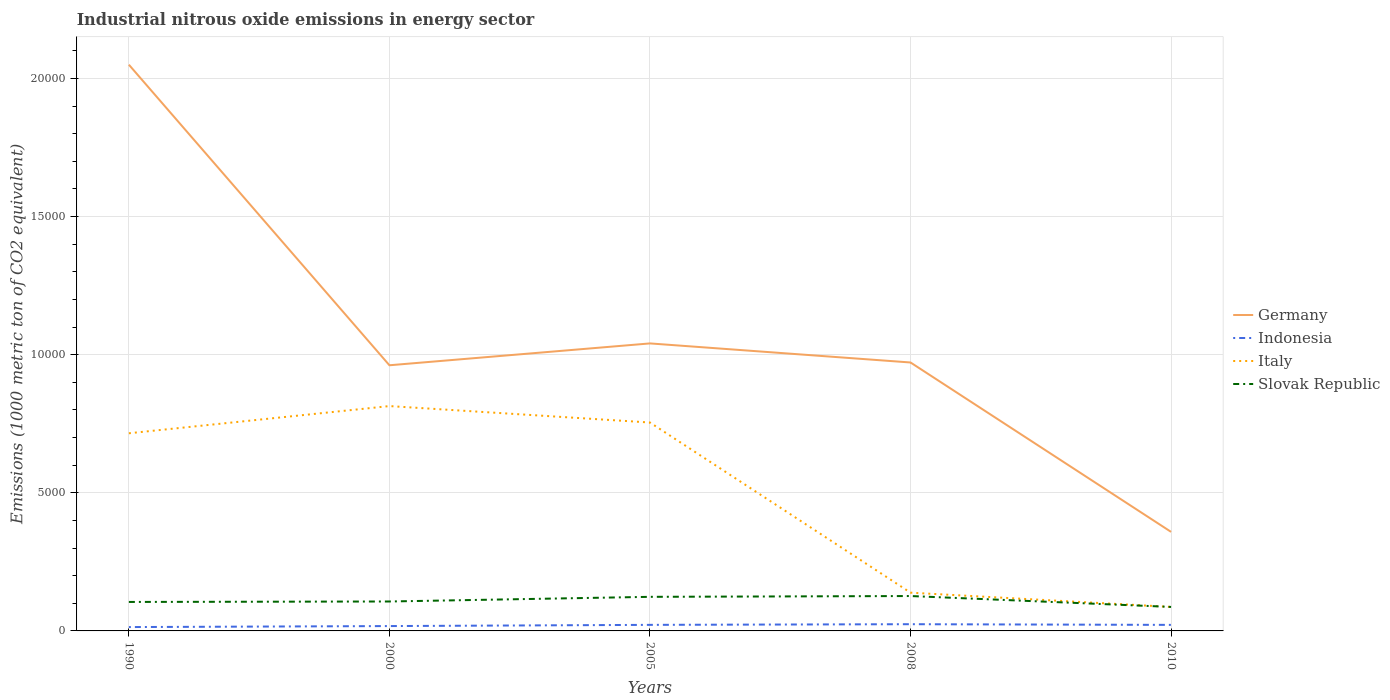How many different coloured lines are there?
Offer a very short reply. 4. Across all years, what is the maximum amount of industrial nitrous oxide emitted in Indonesia?
Offer a very short reply. 139.5. In which year was the amount of industrial nitrous oxide emitted in Germany maximum?
Keep it short and to the point. 2010. What is the total amount of industrial nitrous oxide emitted in Slovak Republic in the graph?
Your answer should be very brief. 394.6. What is the difference between the highest and the second highest amount of industrial nitrous oxide emitted in Slovak Republic?
Your answer should be compact. 394.6. What is the difference between the highest and the lowest amount of industrial nitrous oxide emitted in Italy?
Keep it short and to the point. 3. How many years are there in the graph?
Your response must be concise. 5. What is the difference between two consecutive major ticks on the Y-axis?
Make the answer very short. 5000. Are the values on the major ticks of Y-axis written in scientific E-notation?
Provide a succinct answer. No. How many legend labels are there?
Ensure brevity in your answer.  4. What is the title of the graph?
Offer a very short reply. Industrial nitrous oxide emissions in energy sector. Does "Ethiopia" appear as one of the legend labels in the graph?
Offer a terse response. No. What is the label or title of the X-axis?
Make the answer very short. Years. What is the label or title of the Y-axis?
Your response must be concise. Emissions (1000 metric ton of CO2 equivalent). What is the Emissions (1000 metric ton of CO2 equivalent) of Germany in 1990?
Provide a succinct answer. 2.05e+04. What is the Emissions (1000 metric ton of CO2 equivalent) in Indonesia in 1990?
Keep it short and to the point. 139.5. What is the Emissions (1000 metric ton of CO2 equivalent) in Italy in 1990?
Give a very brief answer. 7155.8. What is the Emissions (1000 metric ton of CO2 equivalent) in Slovak Republic in 1990?
Your response must be concise. 1049. What is the Emissions (1000 metric ton of CO2 equivalent) in Germany in 2000?
Offer a terse response. 9617.9. What is the Emissions (1000 metric ton of CO2 equivalent) of Indonesia in 2000?
Ensure brevity in your answer.  175.8. What is the Emissions (1000 metric ton of CO2 equivalent) of Italy in 2000?
Provide a succinct answer. 8140.4. What is the Emissions (1000 metric ton of CO2 equivalent) in Slovak Republic in 2000?
Provide a short and direct response. 1065.7. What is the Emissions (1000 metric ton of CO2 equivalent) in Germany in 2005?
Provide a succinct answer. 1.04e+04. What is the Emissions (1000 metric ton of CO2 equivalent) of Indonesia in 2005?
Offer a terse response. 219.6. What is the Emissions (1000 metric ton of CO2 equivalent) in Italy in 2005?
Your answer should be very brief. 7544.9. What is the Emissions (1000 metric ton of CO2 equivalent) of Slovak Republic in 2005?
Make the answer very short. 1234.3. What is the Emissions (1000 metric ton of CO2 equivalent) in Germany in 2008?
Your answer should be compact. 9718.4. What is the Emissions (1000 metric ton of CO2 equivalent) in Indonesia in 2008?
Ensure brevity in your answer.  243.3. What is the Emissions (1000 metric ton of CO2 equivalent) of Italy in 2008?
Make the answer very short. 1385.2. What is the Emissions (1000 metric ton of CO2 equivalent) of Slovak Republic in 2008?
Offer a very short reply. 1263.1. What is the Emissions (1000 metric ton of CO2 equivalent) of Germany in 2010?
Your answer should be compact. 3585.4. What is the Emissions (1000 metric ton of CO2 equivalent) of Indonesia in 2010?
Offer a very short reply. 218.6. What is the Emissions (1000 metric ton of CO2 equivalent) in Italy in 2010?
Offer a terse response. 868. What is the Emissions (1000 metric ton of CO2 equivalent) of Slovak Republic in 2010?
Your answer should be compact. 868.5. Across all years, what is the maximum Emissions (1000 metric ton of CO2 equivalent) in Germany?
Provide a short and direct response. 2.05e+04. Across all years, what is the maximum Emissions (1000 metric ton of CO2 equivalent) of Indonesia?
Ensure brevity in your answer.  243.3. Across all years, what is the maximum Emissions (1000 metric ton of CO2 equivalent) of Italy?
Your answer should be very brief. 8140.4. Across all years, what is the maximum Emissions (1000 metric ton of CO2 equivalent) of Slovak Republic?
Offer a terse response. 1263.1. Across all years, what is the minimum Emissions (1000 metric ton of CO2 equivalent) of Germany?
Ensure brevity in your answer.  3585.4. Across all years, what is the minimum Emissions (1000 metric ton of CO2 equivalent) in Indonesia?
Ensure brevity in your answer.  139.5. Across all years, what is the minimum Emissions (1000 metric ton of CO2 equivalent) in Italy?
Provide a short and direct response. 868. Across all years, what is the minimum Emissions (1000 metric ton of CO2 equivalent) in Slovak Republic?
Your response must be concise. 868.5. What is the total Emissions (1000 metric ton of CO2 equivalent) in Germany in the graph?
Provide a short and direct response. 5.38e+04. What is the total Emissions (1000 metric ton of CO2 equivalent) of Indonesia in the graph?
Your response must be concise. 996.8. What is the total Emissions (1000 metric ton of CO2 equivalent) in Italy in the graph?
Make the answer very short. 2.51e+04. What is the total Emissions (1000 metric ton of CO2 equivalent) in Slovak Republic in the graph?
Provide a short and direct response. 5480.6. What is the difference between the Emissions (1000 metric ton of CO2 equivalent) in Germany in 1990 and that in 2000?
Your answer should be compact. 1.09e+04. What is the difference between the Emissions (1000 metric ton of CO2 equivalent) in Indonesia in 1990 and that in 2000?
Offer a very short reply. -36.3. What is the difference between the Emissions (1000 metric ton of CO2 equivalent) of Italy in 1990 and that in 2000?
Your response must be concise. -984.6. What is the difference between the Emissions (1000 metric ton of CO2 equivalent) of Slovak Republic in 1990 and that in 2000?
Offer a very short reply. -16.7. What is the difference between the Emissions (1000 metric ton of CO2 equivalent) of Germany in 1990 and that in 2005?
Make the answer very short. 1.01e+04. What is the difference between the Emissions (1000 metric ton of CO2 equivalent) of Indonesia in 1990 and that in 2005?
Your answer should be very brief. -80.1. What is the difference between the Emissions (1000 metric ton of CO2 equivalent) of Italy in 1990 and that in 2005?
Make the answer very short. -389.1. What is the difference between the Emissions (1000 metric ton of CO2 equivalent) of Slovak Republic in 1990 and that in 2005?
Your answer should be compact. -185.3. What is the difference between the Emissions (1000 metric ton of CO2 equivalent) of Germany in 1990 and that in 2008?
Keep it short and to the point. 1.08e+04. What is the difference between the Emissions (1000 metric ton of CO2 equivalent) of Indonesia in 1990 and that in 2008?
Give a very brief answer. -103.8. What is the difference between the Emissions (1000 metric ton of CO2 equivalent) of Italy in 1990 and that in 2008?
Give a very brief answer. 5770.6. What is the difference between the Emissions (1000 metric ton of CO2 equivalent) in Slovak Republic in 1990 and that in 2008?
Give a very brief answer. -214.1. What is the difference between the Emissions (1000 metric ton of CO2 equivalent) in Germany in 1990 and that in 2010?
Offer a very short reply. 1.69e+04. What is the difference between the Emissions (1000 metric ton of CO2 equivalent) of Indonesia in 1990 and that in 2010?
Make the answer very short. -79.1. What is the difference between the Emissions (1000 metric ton of CO2 equivalent) in Italy in 1990 and that in 2010?
Give a very brief answer. 6287.8. What is the difference between the Emissions (1000 metric ton of CO2 equivalent) of Slovak Republic in 1990 and that in 2010?
Provide a short and direct response. 180.5. What is the difference between the Emissions (1000 metric ton of CO2 equivalent) of Germany in 2000 and that in 2005?
Keep it short and to the point. -791. What is the difference between the Emissions (1000 metric ton of CO2 equivalent) of Indonesia in 2000 and that in 2005?
Offer a terse response. -43.8. What is the difference between the Emissions (1000 metric ton of CO2 equivalent) in Italy in 2000 and that in 2005?
Provide a short and direct response. 595.5. What is the difference between the Emissions (1000 metric ton of CO2 equivalent) of Slovak Republic in 2000 and that in 2005?
Offer a terse response. -168.6. What is the difference between the Emissions (1000 metric ton of CO2 equivalent) of Germany in 2000 and that in 2008?
Your response must be concise. -100.5. What is the difference between the Emissions (1000 metric ton of CO2 equivalent) in Indonesia in 2000 and that in 2008?
Offer a very short reply. -67.5. What is the difference between the Emissions (1000 metric ton of CO2 equivalent) of Italy in 2000 and that in 2008?
Keep it short and to the point. 6755.2. What is the difference between the Emissions (1000 metric ton of CO2 equivalent) in Slovak Republic in 2000 and that in 2008?
Make the answer very short. -197.4. What is the difference between the Emissions (1000 metric ton of CO2 equivalent) of Germany in 2000 and that in 2010?
Give a very brief answer. 6032.5. What is the difference between the Emissions (1000 metric ton of CO2 equivalent) in Indonesia in 2000 and that in 2010?
Provide a short and direct response. -42.8. What is the difference between the Emissions (1000 metric ton of CO2 equivalent) in Italy in 2000 and that in 2010?
Offer a very short reply. 7272.4. What is the difference between the Emissions (1000 metric ton of CO2 equivalent) of Slovak Republic in 2000 and that in 2010?
Make the answer very short. 197.2. What is the difference between the Emissions (1000 metric ton of CO2 equivalent) of Germany in 2005 and that in 2008?
Provide a short and direct response. 690.5. What is the difference between the Emissions (1000 metric ton of CO2 equivalent) of Indonesia in 2005 and that in 2008?
Provide a short and direct response. -23.7. What is the difference between the Emissions (1000 metric ton of CO2 equivalent) of Italy in 2005 and that in 2008?
Your response must be concise. 6159.7. What is the difference between the Emissions (1000 metric ton of CO2 equivalent) in Slovak Republic in 2005 and that in 2008?
Keep it short and to the point. -28.8. What is the difference between the Emissions (1000 metric ton of CO2 equivalent) of Germany in 2005 and that in 2010?
Offer a very short reply. 6823.5. What is the difference between the Emissions (1000 metric ton of CO2 equivalent) in Indonesia in 2005 and that in 2010?
Make the answer very short. 1. What is the difference between the Emissions (1000 metric ton of CO2 equivalent) in Italy in 2005 and that in 2010?
Provide a succinct answer. 6676.9. What is the difference between the Emissions (1000 metric ton of CO2 equivalent) in Slovak Republic in 2005 and that in 2010?
Give a very brief answer. 365.8. What is the difference between the Emissions (1000 metric ton of CO2 equivalent) in Germany in 2008 and that in 2010?
Provide a short and direct response. 6133. What is the difference between the Emissions (1000 metric ton of CO2 equivalent) in Indonesia in 2008 and that in 2010?
Keep it short and to the point. 24.7. What is the difference between the Emissions (1000 metric ton of CO2 equivalent) of Italy in 2008 and that in 2010?
Your answer should be very brief. 517.2. What is the difference between the Emissions (1000 metric ton of CO2 equivalent) in Slovak Republic in 2008 and that in 2010?
Provide a succinct answer. 394.6. What is the difference between the Emissions (1000 metric ton of CO2 equivalent) in Germany in 1990 and the Emissions (1000 metric ton of CO2 equivalent) in Indonesia in 2000?
Offer a very short reply. 2.03e+04. What is the difference between the Emissions (1000 metric ton of CO2 equivalent) of Germany in 1990 and the Emissions (1000 metric ton of CO2 equivalent) of Italy in 2000?
Your answer should be very brief. 1.24e+04. What is the difference between the Emissions (1000 metric ton of CO2 equivalent) of Germany in 1990 and the Emissions (1000 metric ton of CO2 equivalent) of Slovak Republic in 2000?
Provide a short and direct response. 1.94e+04. What is the difference between the Emissions (1000 metric ton of CO2 equivalent) in Indonesia in 1990 and the Emissions (1000 metric ton of CO2 equivalent) in Italy in 2000?
Provide a succinct answer. -8000.9. What is the difference between the Emissions (1000 metric ton of CO2 equivalent) in Indonesia in 1990 and the Emissions (1000 metric ton of CO2 equivalent) in Slovak Republic in 2000?
Your answer should be compact. -926.2. What is the difference between the Emissions (1000 metric ton of CO2 equivalent) of Italy in 1990 and the Emissions (1000 metric ton of CO2 equivalent) of Slovak Republic in 2000?
Offer a terse response. 6090.1. What is the difference between the Emissions (1000 metric ton of CO2 equivalent) in Germany in 1990 and the Emissions (1000 metric ton of CO2 equivalent) in Indonesia in 2005?
Keep it short and to the point. 2.03e+04. What is the difference between the Emissions (1000 metric ton of CO2 equivalent) in Germany in 1990 and the Emissions (1000 metric ton of CO2 equivalent) in Italy in 2005?
Make the answer very short. 1.30e+04. What is the difference between the Emissions (1000 metric ton of CO2 equivalent) of Germany in 1990 and the Emissions (1000 metric ton of CO2 equivalent) of Slovak Republic in 2005?
Provide a succinct answer. 1.93e+04. What is the difference between the Emissions (1000 metric ton of CO2 equivalent) of Indonesia in 1990 and the Emissions (1000 metric ton of CO2 equivalent) of Italy in 2005?
Ensure brevity in your answer.  -7405.4. What is the difference between the Emissions (1000 metric ton of CO2 equivalent) in Indonesia in 1990 and the Emissions (1000 metric ton of CO2 equivalent) in Slovak Republic in 2005?
Your answer should be compact. -1094.8. What is the difference between the Emissions (1000 metric ton of CO2 equivalent) in Italy in 1990 and the Emissions (1000 metric ton of CO2 equivalent) in Slovak Republic in 2005?
Give a very brief answer. 5921.5. What is the difference between the Emissions (1000 metric ton of CO2 equivalent) in Germany in 1990 and the Emissions (1000 metric ton of CO2 equivalent) in Indonesia in 2008?
Offer a terse response. 2.03e+04. What is the difference between the Emissions (1000 metric ton of CO2 equivalent) in Germany in 1990 and the Emissions (1000 metric ton of CO2 equivalent) in Italy in 2008?
Offer a very short reply. 1.91e+04. What is the difference between the Emissions (1000 metric ton of CO2 equivalent) in Germany in 1990 and the Emissions (1000 metric ton of CO2 equivalent) in Slovak Republic in 2008?
Your response must be concise. 1.92e+04. What is the difference between the Emissions (1000 metric ton of CO2 equivalent) in Indonesia in 1990 and the Emissions (1000 metric ton of CO2 equivalent) in Italy in 2008?
Offer a very short reply. -1245.7. What is the difference between the Emissions (1000 metric ton of CO2 equivalent) in Indonesia in 1990 and the Emissions (1000 metric ton of CO2 equivalent) in Slovak Republic in 2008?
Provide a succinct answer. -1123.6. What is the difference between the Emissions (1000 metric ton of CO2 equivalent) in Italy in 1990 and the Emissions (1000 metric ton of CO2 equivalent) in Slovak Republic in 2008?
Ensure brevity in your answer.  5892.7. What is the difference between the Emissions (1000 metric ton of CO2 equivalent) of Germany in 1990 and the Emissions (1000 metric ton of CO2 equivalent) of Indonesia in 2010?
Your answer should be very brief. 2.03e+04. What is the difference between the Emissions (1000 metric ton of CO2 equivalent) in Germany in 1990 and the Emissions (1000 metric ton of CO2 equivalent) in Italy in 2010?
Keep it short and to the point. 1.96e+04. What is the difference between the Emissions (1000 metric ton of CO2 equivalent) of Germany in 1990 and the Emissions (1000 metric ton of CO2 equivalent) of Slovak Republic in 2010?
Ensure brevity in your answer.  1.96e+04. What is the difference between the Emissions (1000 metric ton of CO2 equivalent) of Indonesia in 1990 and the Emissions (1000 metric ton of CO2 equivalent) of Italy in 2010?
Keep it short and to the point. -728.5. What is the difference between the Emissions (1000 metric ton of CO2 equivalent) in Indonesia in 1990 and the Emissions (1000 metric ton of CO2 equivalent) in Slovak Republic in 2010?
Ensure brevity in your answer.  -729. What is the difference between the Emissions (1000 metric ton of CO2 equivalent) in Italy in 1990 and the Emissions (1000 metric ton of CO2 equivalent) in Slovak Republic in 2010?
Your answer should be very brief. 6287.3. What is the difference between the Emissions (1000 metric ton of CO2 equivalent) of Germany in 2000 and the Emissions (1000 metric ton of CO2 equivalent) of Indonesia in 2005?
Your answer should be very brief. 9398.3. What is the difference between the Emissions (1000 metric ton of CO2 equivalent) in Germany in 2000 and the Emissions (1000 metric ton of CO2 equivalent) in Italy in 2005?
Offer a terse response. 2073. What is the difference between the Emissions (1000 metric ton of CO2 equivalent) of Germany in 2000 and the Emissions (1000 metric ton of CO2 equivalent) of Slovak Republic in 2005?
Offer a very short reply. 8383.6. What is the difference between the Emissions (1000 metric ton of CO2 equivalent) in Indonesia in 2000 and the Emissions (1000 metric ton of CO2 equivalent) in Italy in 2005?
Make the answer very short. -7369.1. What is the difference between the Emissions (1000 metric ton of CO2 equivalent) in Indonesia in 2000 and the Emissions (1000 metric ton of CO2 equivalent) in Slovak Republic in 2005?
Keep it short and to the point. -1058.5. What is the difference between the Emissions (1000 metric ton of CO2 equivalent) in Italy in 2000 and the Emissions (1000 metric ton of CO2 equivalent) in Slovak Republic in 2005?
Your response must be concise. 6906.1. What is the difference between the Emissions (1000 metric ton of CO2 equivalent) of Germany in 2000 and the Emissions (1000 metric ton of CO2 equivalent) of Indonesia in 2008?
Keep it short and to the point. 9374.6. What is the difference between the Emissions (1000 metric ton of CO2 equivalent) in Germany in 2000 and the Emissions (1000 metric ton of CO2 equivalent) in Italy in 2008?
Your response must be concise. 8232.7. What is the difference between the Emissions (1000 metric ton of CO2 equivalent) in Germany in 2000 and the Emissions (1000 metric ton of CO2 equivalent) in Slovak Republic in 2008?
Your answer should be very brief. 8354.8. What is the difference between the Emissions (1000 metric ton of CO2 equivalent) in Indonesia in 2000 and the Emissions (1000 metric ton of CO2 equivalent) in Italy in 2008?
Provide a short and direct response. -1209.4. What is the difference between the Emissions (1000 metric ton of CO2 equivalent) in Indonesia in 2000 and the Emissions (1000 metric ton of CO2 equivalent) in Slovak Republic in 2008?
Make the answer very short. -1087.3. What is the difference between the Emissions (1000 metric ton of CO2 equivalent) of Italy in 2000 and the Emissions (1000 metric ton of CO2 equivalent) of Slovak Republic in 2008?
Offer a terse response. 6877.3. What is the difference between the Emissions (1000 metric ton of CO2 equivalent) in Germany in 2000 and the Emissions (1000 metric ton of CO2 equivalent) in Indonesia in 2010?
Ensure brevity in your answer.  9399.3. What is the difference between the Emissions (1000 metric ton of CO2 equivalent) in Germany in 2000 and the Emissions (1000 metric ton of CO2 equivalent) in Italy in 2010?
Provide a succinct answer. 8749.9. What is the difference between the Emissions (1000 metric ton of CO2 equivalent) in Germany in 2000 and the Emissions (1000 metric ton of CO2 equivalent) in Slovak Republic in 2010?
Your answer should be very brief. 8749.4. What is the difference between the Emissions (1000 metric ton of CO2 equivalent) of Indonesia in 2000 and the Emissions (1000 metric ton of CO2 equivalent) of Italy in 2010?
Offer a terse response. -692.2. What is the difference between the Emissions (1000 metric ton of CO2 equivalent) in Indonesia in 2000 and the Emissions (1000 metric ton of CO2 equivalent) in Slovak Republic in 2010?
Ensure brevity in your answer.  -692.7. What is the difference between the Emissions (1000 metric ton of CO2 equivalent) of Italy in 2000 and the Emissions (1000 metric ton of CO2 equivalent) of Slovak Republic in 2010?
Provide a short and direct response. 7271.9. What is the difference between the Emissions (1000 metric ton of CO2 equivalent) of Germany in 2005 and the Emissions (1000 metric ton of CO2 equivalent) of Indonesia in 2008?
Provide a succinct answer. 1.02e+04. What is the difference between the Emissions (1000 metric ton of CO2 equivalent) of Germany in 2005 and the Emissions (1000 metric ton of CO2 equivalent) of Italy in 2008?
Offer a very short reply. 9023.7. What is the difference between the Emissions (1000 metric ton of CO2 equivalent) of Germany in 2005 and the Emissions (1000 metric ton of CO2 equivalent) of Slovak Republic in 2008?
Give a very brief answer. 9145.8. What is the difference between the Emissions (1000 metric ton of CO2 equivalent) in Indonesia in 2005 and the Emissions (1000 metric ton of CO2 equivalent) in Italy in 2008?
Your answer should be compact. -1165.6. What is the difference between the Emissions (1000 metric ton of CO2 equivalent) in Indonesia in 2005 and the Emissions (1000 metric ton of CO2 equivalent) in Slovak Republic in 2008?
Your answer should be compact. -1043.5. What is the difference between the Emissions (1000 metric ton of CO2 equivalent) in Italy in 2005 and the Emissions (1000 metric ton of CO2 equivalent) in Slovak Republic in 2008?
Give a very brief answer. 6281.8. What is the difference between the Emissions (1000 metric ton of CO2 equivalent) of Germany in 2005 and the Emissions (1000 metric ton of CO2 equivalent) of Indonesia in 2010?
Offer a terse response. 1.02e+04. What is the difference between the Emissions (1000 metric ton of CO2 equivalent) of Germany in 2005 and the Emissions (1000 metric ton of CO2 equivalent) of Italy in 2010?
Provide a short and direct response. 9540.9. What is the difference between the Emissions (1000 metric ton of CO2 equivalent) in Germany in 2005 and the Emissions (1000 metric ton of CO2 equivalent) in Slovak Republic in 2010?
Offer a terse response. 9540.4. What is the difference between the Emissions (1000 metric ton of CO2 equivalent) in Indonesia in 2005 and the Emissions (1000 metric ton of CO2 equivalent) in Italy in 2010?
Your answer should be very brief. -648.4. What is the difference between the Emissions (1000 metric ton of CO2 equivalent) of Indonesia in 2005 and the Emissions (1000 metric ton of CO2 equivalent) of Slovak Republic in 2010?
Offer a very short reply. -648.9. What is the difference between the Emissions (1000 metric ton of CO2 equivalent) in Italy in 2005 and the Emissions (1000 metric ton of CO2 equivalent) in Slovak Republic in 2010?
Provide a succinct answer. 6676.4. What is the difference between the Emissions (1000 metric ton of CO2 equivalent) of Germany in 2008 and the Emissions (1000 metric ton of CO2 equivalent) of Indonesia in 2010?
Offer a terse response. 9499.8. What is the difference between the Emissions (1000 metric ton of CO2 equivalent) of Germany in 2008 and the Emissions (1000 metric ton of CO2 equivalent) of Italy in 2010?
Provide a succinct answer. 8850.4. What is the difference between the Emissions (1000 metric ton of CO2 equivalent) in Germany in 2008 and the Emissions (1000 metric ton of CO2 equivalent) in Slovak Republic in 2010?
Give a very brief answer. 8849.9. What is the difference between the Emissions (1000 metric ton of CO2 equivalent) in Indonesia in 2008 and the Emissions (1000 metric ton of CO2 equivalent) in Italy in 2010?
Provide a short and direct response. -624.7. What is the difference between the Emissions (1000 metric ton of CO2 equivalent) in Indonesia in 2008 and the Emissions (1000 metric ton of CO2 equivalent) in Slovak Republic in 2010?
Give a very brief answer. -625.2. What is the difference between the Emissions (1000 metric ton of CO2 equivalent) in Italy in 2008 and the Emissions (1000 metric ton of CO2 equivalent) in Slovak Republic in 2010?
Provide a succinct answer. 516.7. What is the average Emissions (1000 metric ton of CO2 equivalent) of Germany per year?
Give a very brief answer. 1.08e+04. What is the average Emissions (1000 metric ton of CO2 equivalent) in Indonesia per year?
Offer a very short reply. 199.36. What is the average Emissions (1000 metric ton of CO2 equivalent) of Italy per year?
Your response must be concise. 5018.86. What is the average Emissions (1000 metric ton of CO2 equivalent) in Slovak Republic per year?
Ensure brevity in your answer.  1096.12. In the year 1990, what is the difference between the Emissions (1000 metric ton of CO2 equivalent) in Germany and Emissions (1000 metric ton of CO2 equivalent) in Indonesia?
Make the answer very short. 2.04e+04. In the year 1990, what is the difference between the Emissions (1000 metric ton of CO2 equivalent) in Germany and Emissions (1000 metric ton of CO2 equivalent) in Italy?
Offer a terse response. 1.33e+04. In the year 1990, what is the difference between the Emissions (1000 metric ton of CO2 equivalent) in Germany and Emissions (1000 metric ton of CO2 equivalent) in Slovak Republic?
Keep it short and to the point. 1.95e+04. In the year 1990, what is the difference between the Emissions (1000 metric ton of CO2 equivalent) in Indonesia and Emissions (1000 metric ton of CO2 equivalent) in Italy?
Offer a terse response. -7016.3. In the year 1990, what is the difference between the Emissions (1000 metric ton of CO2 equivalent) in Indonesia and Emissions (1000 metric ton of CO2 equivalent) in Slovak Republic?
Offer a terse response. -909.5. In the year 1990, what is the difference between the Emissions (1000 metric ton of CO2 equivalent) of Italy and Emissions (1000 metric ton of CO2 equivalent) of Slovak Republic?
Your response must be concise. 6106.8. In the year 2000, what is the difference between the Emissions (1000 metric ton of CO2 equivalent) in Germany and Emissions (1000 metric ton of CO2 equivalent) in Indonesia?
Give a very brief answer. 9442.1. In the year 2000, what is the difference between the Emissions (1000 metric ton of CO2 equivalent) in Germany and Emissions (1000 metric ton of CO2 equivalent) in Italy?
Provide a short and direct response. 1477.5. In the year 2000, what is the difference between the Emissions (1000 metric ton of CO2 equivalent) in Germany and Emissions (1000 metric ton of CO2 equivalent) in Slovak Republic?
Offer a very short reply. 8552.2. In the year 2000, what is the difference between the Emissions (1000 metric ton of CO2 equivalent) in Indonesia and Emissions (1000 metric ton of CO2 equivalent) in Italy?
Your answer should be compact. -7964.6. In the year 2000, what is the difference between the Emissions (1000 metric ton of CO2 equivalent) in Indonesia and Emissions (1000 metric ton of CO2 equivalent) in Slovak Republic?
Provide a short and direct response. -889.9. In the year 2000, what is the difference between the Emissions (1000 metric ton of CO2 equivalent) of Italy and Emissions (1000 metric ton of CO2 equivalent) of Slovak Republic?
Your answer should be compact. 7074.7. In the year 2005, what is the difference between the Emissions (1000 metric ton of CO2 equivalent) in Germany and Emissions (1000 metric ton of CO2 equivalent) in Indonesia?
Offer a terse response. 1.02e+04. In the year 2005, what is the difference between the Emissions (1000 metric ton of CO2 equivalent) in Germany and Emissions (1000 metric ton of CO2 equivalent) in Italy?
Provide a short and direct response. 2864. In the year 2005, what is the difference between the Emissions (1000 metric ton of CO2 equivalent) in Germany and Emissions (1000 metric ton of CO2 equivalent) in Slovak Republic?
Provide a short and direct response. 9174.6. In the year 2005, what is the difference between the Emissions (1000 metric ton of CO2 equivalent) in Indonesia and Emissions (1000 metric ton of CO2 equivalent) in Italy?
Ensure brevity in your answer.  -7325.3. In the year 2005, what is the difference between the Emissions (1000 metric ton of CO2 equivalent) of Indonesia and Emissions (1000 metric ton of CO2 equivalent) of Slovak Republic?
Provide a short and direct response. -1014.7. In the year 2005, what is the difference between the Emissions (1000 metric ton of CO2 equivalent) of Italy and Emissions (1000 metric ton of CO2 equivalent) of Slovak Republic?
Provide a succinct answer. 6310.6. In the year 2008, what is the difference between the Emissions (1000 metric ton of CO2 equivalent) in Germany and Emissions (1000 metric ton of CO2 equivalent) in Indonesia?
Your answer should be very brief. 9475.1. In the year 2008, what is the difference between the Emissions (1000 metric ton of CO2 equivalent) in Germany and Emissions (1000 metric ton of CO2 equivalent) in Italy?
Your answer should be very brief. 8333.2. In the year 2008, what is the difference between the Emissions (1000 metric ton of CO2 equivalent) in Germany and Emissions (1000 metric ton of CO2 equivalent) in Slovak Republic?
Provide a succinct answer. 8455.3. In the year 2008, what is the difference between the Emissions (1000 metric ton of CO2 equivalent) of Indonesia and Emissions (1000 metric ton of CO2 equivalent) of Italy?
Keep it short and to the point. -1141.9. In the year 2008, what is the difference between the Emissions (1000 metric ton of CO2 equivalent) in Indonesia and Emissions (1000 metric ton of CO2 equivalent) in Slovak Republic?
Your answer should be very brief. -1019.8. In the year 2008, what is the difference between the Emissions (1000 metric ton of CO2 equivalent) in Italy and Emissions (1000 metric ton of CO2 equivalent) in Slovak Republic?
Offer a very short reply. 122.1. In the year 2010, what is the difference between the Emissions (1000 metric ton of CO2 equivalent) of Germany and Emissions (1000 metric ton of CO2 equivalent) of Indonesia?
Keep it short and to the point. 3366.8. In the year 2010, what is the difference between the Emissions (1000 metric ton of CO2 equivalent) of Germany and Emissions (1000 metric ton of CO2 equivalent) of Italy?
Offer a terse response. 2717.4. In the year 2010, what is the difference between the Emissions (1000 metric ton of CO2 equivalent) in Germany and Emissions (1000 metric ton of CO2 equivalent) in Slovak Republic?
Ensure brevity in your answer.  2716.9. In the year 2010, what is the difference between the Emissions (1000 metric ton of CO2 equivalent) in Indonesia and Emissions (1000 metric ton of CO2 equivalent) in Italy?
Offer a very short reply. -649.4. In the year 2010, what is the difference between the Emissions (1000 metric ton of CO2 equivalent) in Indonesia and Emissions (1000 metric ton of CO2 equivalent) in Slovak Republic?
Make the answer very short. -649.9. In the year 2010, what is the difference between the Emissions (1000 metric ton of CO2 equivalent) in Italy and Emissions (1000 metric ton of CO2 equivalent) in Slovak Republic?
Offer a terse response. -0.5. What is the ratio of the Emissions (1000 metric ton of CO2 equivalent) in Germany in 1990 to that in 2000?
Keep it short and to the point. 2.13. What is the ratio of the Emissions (1000 metric ton of CO2 equivalent) in Indonesia in 1990 to that in 2000?
Provide a succinct answer. 0.79. What is the ratio of the Emissions (1000 metric ton of CO2 equivalent) in Italy in 1990 to that in 2000?
Your response must be concise. 0.88. What is the ratio of the Emissions (1000 metric ton of CO2 equivalent) in Slovak Republic in 1990 to that in 2000?
Ensure brevity in your answer.  0.98. What is the ratio of the Emissions (1000 metric ton of CO2 equivalent) of Germany in 1990 to that in 2005?
Make the answer very short. 1.97. What is the ratio of the Emissions (1000 metric ton of CO2 equivalent) in Indonesia in 1990 to that in 2005?
Your response must be concise. 0.64. What is the ratio of the Emissions (1000 metric ton of CO2 equivalent) of Italy in 1990 to that in 2005?
Offer a very short reply. 0.95. What is the ratio of the Emissions (1000 metric ton of CO2 equivalent) of Slovak Republic in 1990 to that in 2005?
Keep it short and to the point. 0.85. What is the ratio of the Emissions (1000 metric ton of CO2 equivalent) in Germany in 1990 to that in 2008?
Make the answer very short. 2.11. What is the ratio of the Emissions (1000 metric ton of CO2 equivalent) of Indonesia in 1990 to that in 2008?
Your answer should be compact. 0.57. What is the ratio of the Emissions (1000 metric ton of CO2 equivalent) in Italy in 1990 to that in 2008?
Make the answer very short. 5.17. What is the ratio of the Emissions (1000 metric ton of CO2 equivalent) of Slovak Republic in 1990 to that in 2008?
Your answer should be compact. 0.83. What is the ratio of the Emissions (1000 metric ton of CO2 equivalent) in Germany in 1990 to that in 2010?
Offer a very short reply. 5.72. What is the ratio of the Emissions (1000 metric ton of CO2 equivalent) of Indonesia in 1990 to that in 2010?
Make the answer very short. 0.64. What is the ratio of the Emissions (1000 metric ton of CO2 equivalent) of Italy in 1990 to that in 2010?
Your answer should be very brief. 8.24. What is the ratio of the Emissions (1000 metric ton of CO2 equivalent) in Slovak Republic in 1990 to that in 2010?
Provide a short and direct response. 1.21. What is the ratio of the Emissions (1000 metric ton of CO2 equivalent) of Germany in 2000 to that in 2005?
Make the answer very short. 0.92. What is the ratio of the Emissions (1000 metric ton of CO2 equivalent) of Indonesia in 2000 to that in 2005?
Your answer should be compact. 0.8. What is the ratio of the Emissions (1000 metric ton of CO2 equivalent) of Italy in 2000 to that in 2005?
Give a very brief answer. 1.08. What is the ratio of the Emissions (1000 metric ton of CO2 equivalent) of Slovak Republic in 2000 to that in 2005?
Keep it short and to the point. 0.86. What is the ratio of the Emissions (1000 metric ton of CO2 equivalent) in Germany in 2000 to that in 2008?
Offer a very short reply. 0.99. What is the ratio of the Emissions (1000 metric ton of CO2 equivalent) of Indonesia in 2000 to that in 2008?
Make the answer very short. 0.72. What is the ratio of the Emissions (1000 metric ton of CO2 equivalent) in Italy in 2000 to that in 2008?
Provide a succinct answer. 5.88. What is the ratio of the Emissions (1000 metric ton of CO2 equivalent) of Slovak Republic in 2000 to that in 2008?
Ensure brevity in your answer.  0.84. What is the ratio of the Emissions (1000 metric ton of CO2 equivalent) in Germany in 2000 to that in 2010?
Provide a succinct answer. 2.68. What is the ratio of the Emissions (1000 metric ton of CO2 equivalent) of Indonesia in 2000 to that in 2010?
Keep it short and to the point. 0.8. What is the ratio of the Emissions (1000 metric ton of CO2 equivalent) of Italy in 2000 to that in 2010?
Keep it short and to the point. 9.38. What is the ratio of the Emissions (1000 metric ton of CO2 equivalent) of Slovak Republic in 2000 to that in 2010?
Your response must be concise. 1.23. What is the ratio of the Emissions (1000 metric ton of CO2 equivalent) in Germany in 2005 to that in 2008?
Offer a very short reply. 1.07. What is the ratio of the Emissions (1000 metric ton of CO2 equivalent) in Indonesia in 2005 to that in 2008?
Offer a very short reply. 0.9. What is the ratio of the Emissions (1000 metric ton of CO2 equivalent) of Italy in 2005 to that in 2008?
Ensure brevity in your answer.  5.45. What is the ratio of the Emissions (1000 metric ton of CO2 equivalent) of Slovak Republic in 2005 to that in 2008?
Give a very brief answer. 0.98. What is the ratio of the Emissions (1000 metric ton of CO2 equivalent) in Germany in 2005 to that in 2010?
Provide a succinct answer. 2.9. What is the ratio of the Emissions (1000 metric ton of CO2 equivalent) of Indonesia in 2005 to that in 2010?
Your answer should be very brief. 1. What is the ratio of the Emissions (1000 metric ton of CO2 equivalent) in Italy in 2005 to that in 2010?
Offer a very short reply. 8.69. What is the ratio of the Emissions (1000 metric ton of CO2 equivalent) in Slovak Republic in 2005 to that in 2010?
Offer a very short reply. 1.42. What is the ratio of the Emissions (1000 metric ton of CO2 equivalent) in Germany in 2008 to that in 2010?
Provide a succinct answer. 2.71. What is the ratio of the Emissions (1000 metric ton of CO2 equivalent) of Indonesia in 2008 to that in 2010?
Provide a succinct answer. 1.11. What is the ratio of the Emissions (1000 metric ton of CO2 equivalent) of Italy in 2008 to that in 2010?
Your response must be concise. 1.6. What is the ratio of the Emissions (1000 metric ton of CO2 equivalent) in Slovak Republic in 2008 to that in 2010?
Provide a succinct answer. 1.45. What is the difference between the highest and the second highest Emissions (1000 metric ton of CO2 equivalent) of Germany?
Your answer should be very brief. 1.01e+04. What is the difference between the highest and the second highest Emissions (1000 metric ton of CO2 equivalent) of Indonesia?
Give a very brief answer. 23.7. What is the difference between the highest and the second highest Emissions (1000 metric ton of CO2 equivalent) of Italy?
Offer a terse response. 595.5. What is the difference between the highest and the second highest Emissions (1000 metric ton of CO2 equivalent) of Slovak Republic?
Make the answer very short. 28.8. What is the difference between the highest and the lowest Emissions (1000 metric ton of CO2 equivalent) in Germany?
Keep it short and to the point. 1.69e+04. What is the difference between the highest and the lowest Emissions (1000 metric ton of CO2 equivalent) of Indonesia?
Provide a succinct answer. 103.8. What is the difference between the highest and the lowest Emissions (1000 metric ton of CO2 equivalent) of Italy?
Your answer should be very brief. 7272.4. What is the difference between the highest and the lowest Emissions (1000 metric ton of CO2 equivalent) in Slovak Republic?
Ensure brevity in your answer.  394.6. 